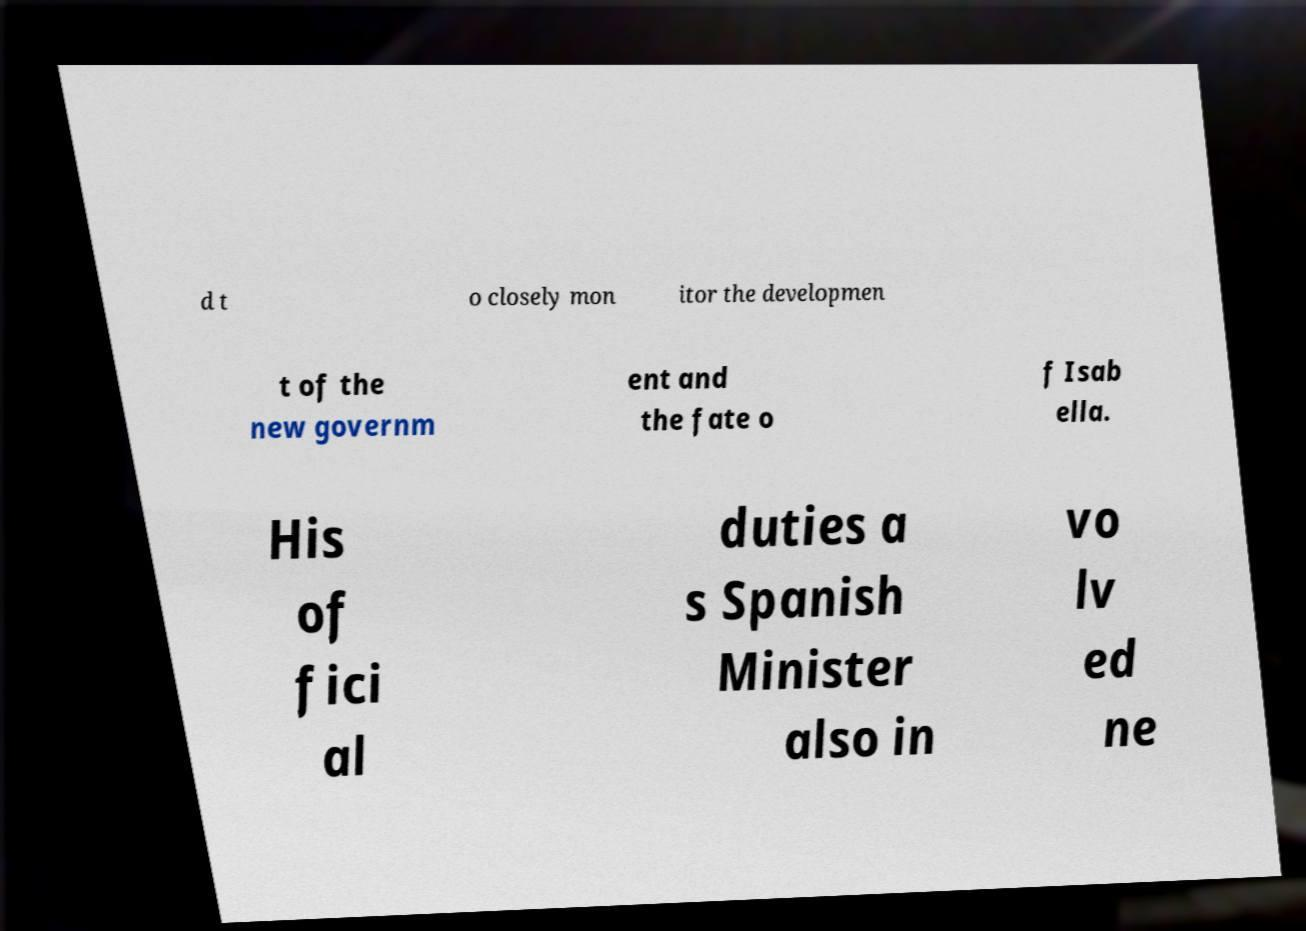I need the written content from this picture converted into text. Can you do that? d t o closely mon itor the developmen t of the new governm ent and the fate o f Isab ella. His of fici al duties a s Spanish Minister also in vo lv ed ne 